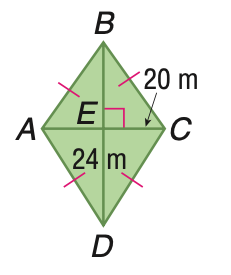Question: Find the area of the quadrilateral.
Choices:
A. 120
B. 240
C. 360
D. 480
Answer with the letter. Answer: B 